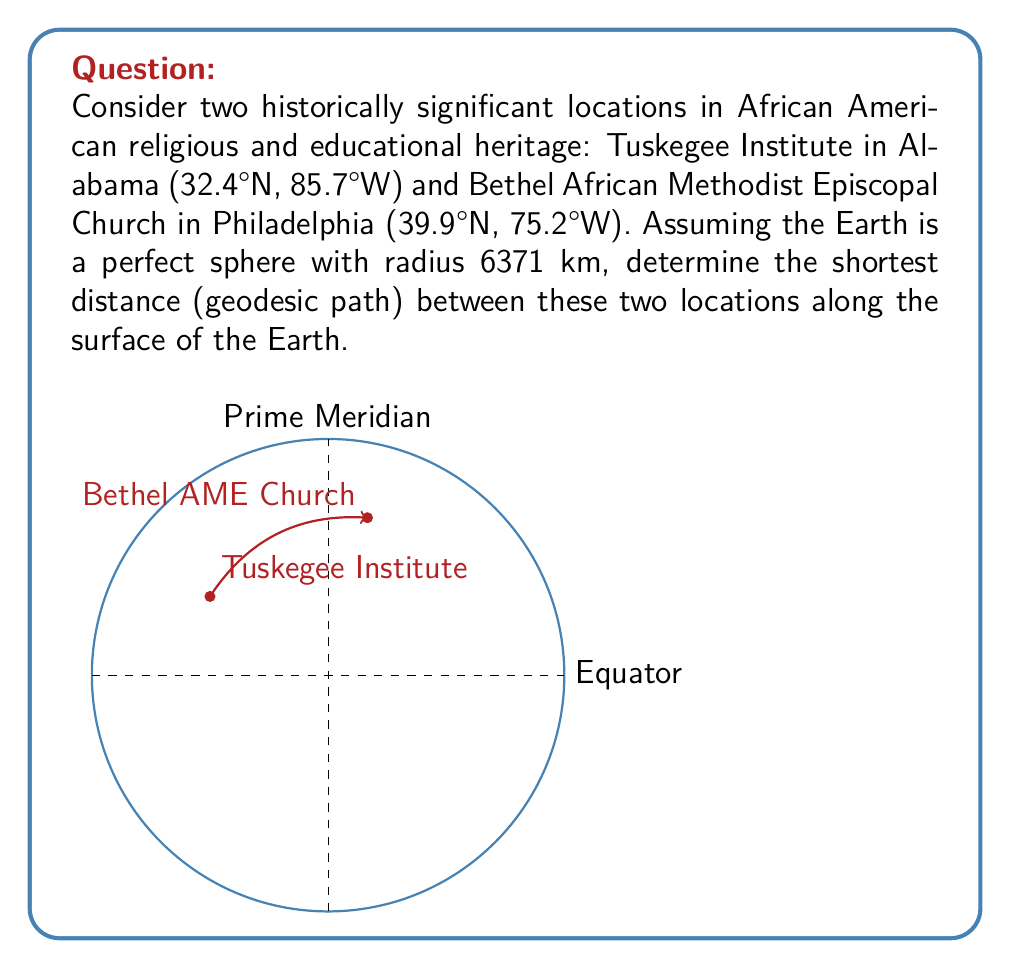Show me your answer to this math problem. To solve this problem, we'll use the spherical law of cosines formula for great circle distances. The steps are as follows:

1) Convert the latitudes and longitudes to radians:
   Tuskegee: $\phi_1 = 32.4° \cdot \frac{\pi}{180} = 0.5655$ rad, $\lambda_1 = -85.7° \cdot \frac{\pi}{180} = -1.4956$ rad
   Bethel AME: $\phi_2 = 39.9° \cdot \frac{\pi}{180} = 0.6965$ rad, $\lambda_2 = -75.2° \cdot \frac{\pi}{180} = -1.3126$ rad

2) Calculate the central angle $\Delta\sigma$ using the spherical law of cosines:
   $$\cos(\Delta\sigma) = \sin(\phi_1)\sin(\phi_2) + \cos(\phi_1)\cos(\phi_2)\cos(|\lambda_2 - \lambda_1|)$$

3) Substitute the values:
   $$\cos(\Delta\sigma) = \sin(0.5655)\sin(0.6965) + \cos(0.5655)\cos(0.6965)\cos(|1.3126 - (-1.4956)|)$$

4) Evaluate:
   $$\cos(\Delta\sigma) = 0.9897$$

5) Take the inverse cosine:
   $$\Delta\sigma = \arccos(0.9897) = 0.1431 \text{ radians}$$

6) Calculate the great circle distance $d$:
   $$d = R \cdot \Delta\sigma$$
   where $R$ is the radius of the Earth (6371 km)

7) Substitute and calculate:
   $$d = 6371 \cdot 0.1431 = 911.7 \text{ km}$$

Therefore, the shortest distance between Tuskegee Institute and Bethel AME Church along the surface of the Earth is approximately 911.7 km.
Answer: 911.7 km 